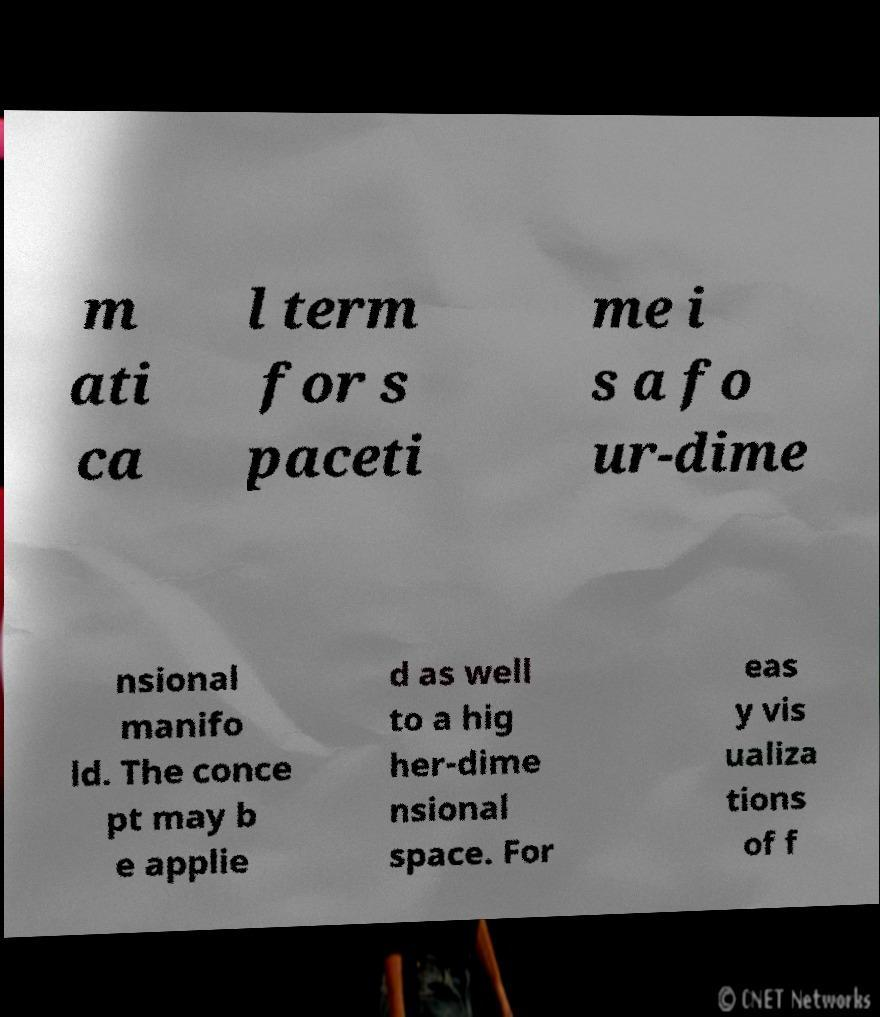Could you assist in decoding the text presented in this image and type it out clearly? m ati ca l term for s paceti me i s a fo ur-dime nsional manifo ld. The conce pt may b e applie d as well to a hig her-dime nsional space. For eas y vis ualiza tions of f 